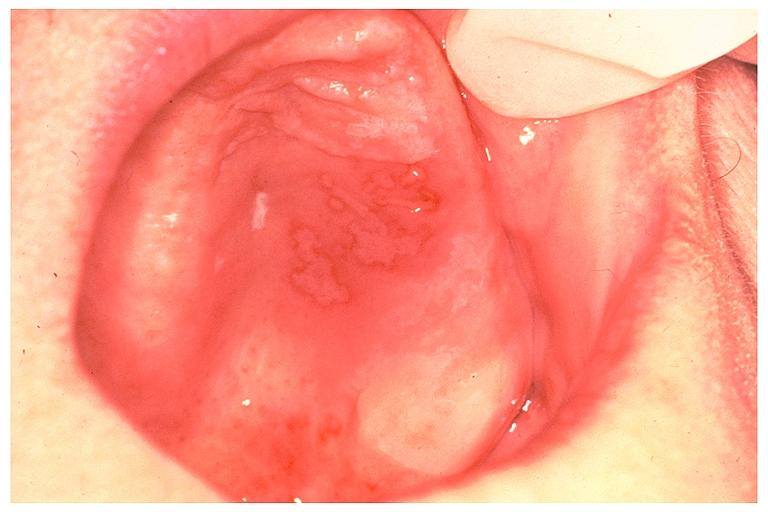does this image show recurrent intraoral herpes simplex?
Answer the question using a single word or phrase. Yes 